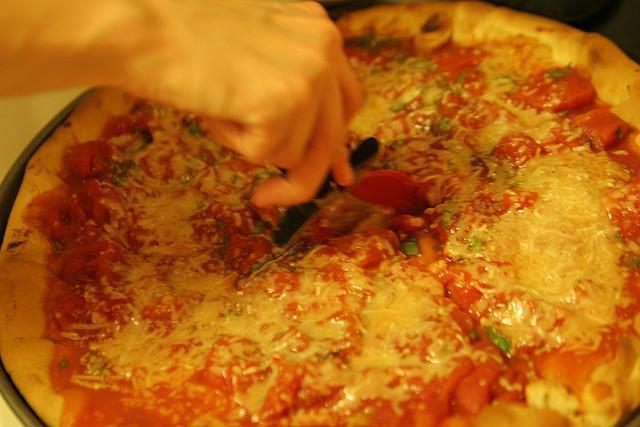Does the description: "The pizza is at the right side of the person." accurately reflect the image?
Answer yes or no. No. Is this affirmation: "The pizza is touching the person." correct?
Answer yes or no. No. 